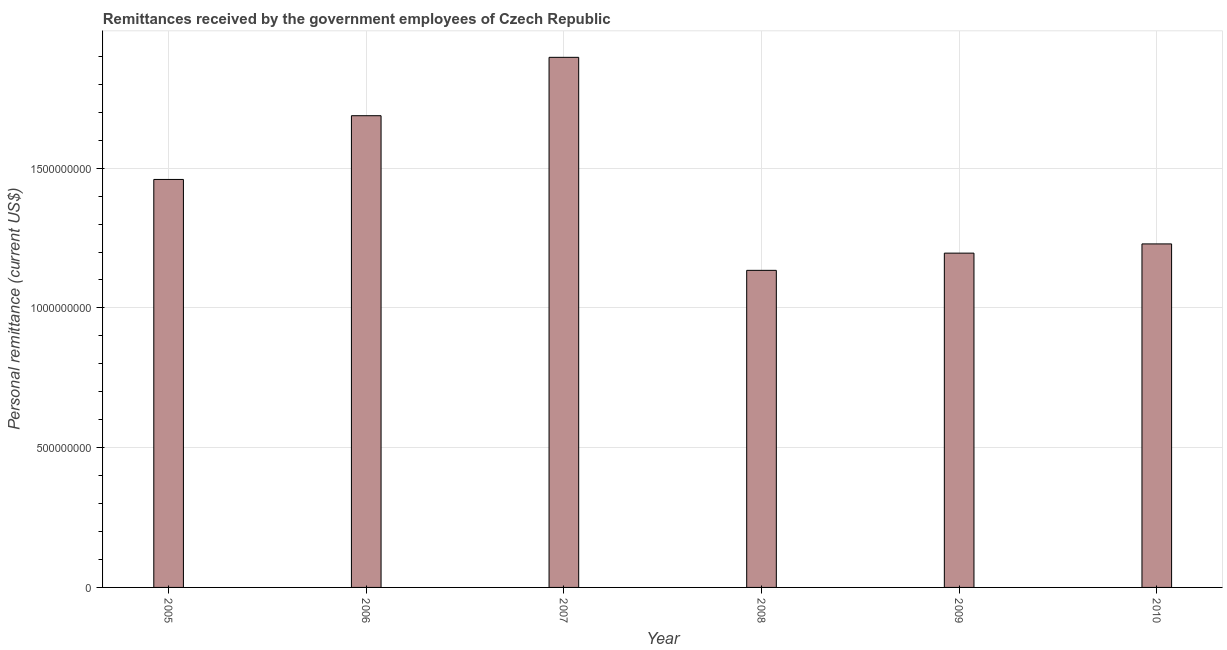Does the graph contain any zero values?
Ensure brevity in your answer.  No. Does the graph contain grids?
Keep it short and to the point. Yes. What is the title of the graph?
Provide a short and direct response. Remittances received by the government employees of Czech Republic. What is the label or title of the X-axis?
Provide a short and direct response. Year. What is the label or title of the Y-axis?
Provide a short and direct response. Personal remittance (current US$). What is the personal remittances in 2007?
Your answer should be compact. 1.90e+09. Across all years, what is the maximum personal remittances?
Ensure brevity in your answer.  1.90e+09. Across all years, what is the minimum personal remittances?
Give a very brief answer. 1.13e+09. In which year was the personal remittances maximum?
Your answer should be very brief. 2007. What is the sum of the personal remittances?
Provide a succinct answer. 8.60e+09. What is the difference between the personal remittances in 2005 and 2007?
Your answer should be very brief. -4.37e+08. What is the average personal remittances per year?
Keep it short and to the point. 1.43e+09. What is the median personal remittances?
Offer a very short reply. 1.34e+09. Do a majority of the years between 2008 and 2009 (inclusive) have personal remittances greater than 1500000000 US$?
Make the answer very short. No. What is the ratio of the personal remittances in 2007 to that in 2010?
Provide a succinct answer. 1.54. Is the difference between the personal remittances in 2007 and 2008 greater than the difference between any two years?
Your response must be concise. Yes. What is the difference between the highest and the second highest personal remittances?
Your answer should be compact. 2.09e+08. What is the difference between the highest and the lowest personal remittances?
Provide a succinct answer. 7.62e+08. Are all the bars in the graph horizontal?
Offer a very short reply. No. What is the difference between two consecutive major ticks on the Y-axis?
Make the answer very short. 5.00e+08. What is the Personal remittance (current US$) of 2005?
Your response must be concise. 1.46e+09. What is the Personal remittance (current US$) of 2006?
Provide a succinct answer. 1.69e+09. What is the Personal remittance (current US$) of 2007?
Your answer should be very brief. 1.90e+09. What is the Personal remittance (current US$) of 2008?
Offer a terse response. 1.13e+09. What is the Personal remittance (current US$) of 2009?
Offer a very short reply. 1.20e+09. What is the Personal remittance (current US$) in 2010?
Offer a terse response. 1.23e+09. What is the difference between the Personal remittance (current US$) in 2005 and 2006?
Your response must be concise. -2.28e+08. What is the difference between the Personal remittance (current US$) in 2005 and 2007?
Your answer should be very brief. -4.37e+08. What is the difference between the Personal remittance (current US$) in 2005 and 2008?
Your answer should be very brief. 3.25e+08. What is the difference between the Personal remittance (current US$) in 2005 and 2009?
Ensure brevity in your answer.  2.64e+08. What is the difference between the Personal remittance (current US$) in 2005 and 2010?
Your answer should be very brief. 2.31e+08. What is the difference between the Personal remittance (current US$) in 2006 and 2007?
Offer a terse response. -2.09e+08. What is the difference between the Personal remittance (current US$) in 2006 and 2008?
Make the answer very short. 5.53e+08. What is the difference between the Personal remittance (current US$) in 2006 and 2009?
Provide a succinct answer. 4.92e+08. What is the difference between the Personal remittance (current US$) in 2006 and 2010?
Make the answer very short. 4.59e+08. What is the difference between the Personal remittance (current US$) in 2007 and 2008?
Make the answer very short. 7.62e+08. What is the difference between the Personal remittance (current US$) in 2007 and 2009?
Provide a succinct answer. 7.01e+08. What is the difference between the Personal remittance (current US$) in 2007 and 2010?
Provide a short and direct response. 6.68e+08. What is the difference between the Personal remittance (current US$) in 2008 and 2009?
Give a very brief answer. -6.16e+07. What is the difference between the Personal remittance (current US$) in 2008 and 2010?
Your answer should be compact. -9.46e+07. What is the difference between the Personal remittance (current US$) in 2009 and 2010?
Offer a terse response. -3.30e+07. What is the ratio of the Personal remittance (current US$) in 2005 to that in 2006?
Keep it short and to the point. 0.86. What is the ratio of the Personal remittance (current US$) in 2005 to that in 2007?
Ensure brevity in your answer.  0.77. What is the ratio of the Personal remittance (current US$) in 2005 to that in 2008?
Ensure brevity in your answer.  1.29. What is the ratio of the Personal remittance (current US$) in 2005 to that in 2009?
Keep it short and to the point. 1.22. What is the ratio of the Personal remittance (current US$) in 2005 to that in 2010?
Keep it short and to the point. 1.19. What is the ratio of the Personal remittance (current US$) in 2006 to that in 2007?
Provide a succinct answer. 0.89. What is the ratio of the Personal remittance (current US$) in 2006 to that in 2008?
Offer a very short reply. 1.49. What is the ratio of the Personal remittance (current US$) in 2006 to that in 2009?
Provide a succinct answer. 1.41. What is the ratio of the Personal remittance (current US$) in 2006 to that in 2010?
Give a very brief answer. 1.37. What is the ratio of the Personal remittance (current US$) in 2007 to that in 2008?
Offer a terse response. 1.67. What is the ratio of the Personal remittance (current US$) in 2007 to that in 2009?
Provide a short and direct response. 1.59. What is the ratio of the Personal remittance (current US$) in 2007 to that in 2010?
Provide a short and direct response. 1.54. What is the ratio of the Personal remittance (current US$) in 2008 to that in 2009?
Your answer should be compact. 0.95. What is the ratio of the Personal remittance (current US$) in 2008 to that in 2010?
Offer a terse response. 0.92. What is the ratio of the Personal remittance (current US$) in 2009 to that in 2010?
Ensure brevity in your answer.  0.97. 